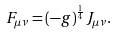Convert formula to latex. <formula><loc_0><loc_0><loc_500><loc_500>F _ { \mu \nu } = ( - g ) ^ { \frac { 1 } { 4 } } J _ { \mu \nu } .</formula> 